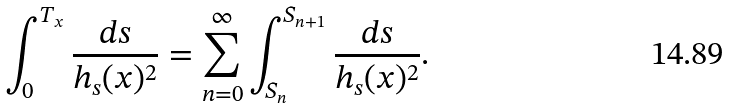Convert formula to latex. <formula><loc_0><loc_0><loc_500><loc_500>\int _ { 0 } ^ { T _ { x } } \frac { d s } { h _ { s } ( x ) ^ { 2 } } = \sum _ { n = 0 } ^ { \infty } \int _ { S _ { n } } ^ { S _ { n + 1 } } \frac { d s } { h _ { s } ( x ) ^ { 2 } } .</formula> 